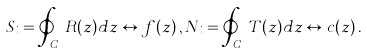<formula> <loc_0><loc_0><loc_500><loc_500>S _ { i } = \oint _ { C _ { i } } R ( z ) d z \leftrightarrow f ( z ) \, , N _ { i } = \oint _ { C _ { i } } T ( z ) d z \leftrightarrow c ( z ) \, .</formula> 